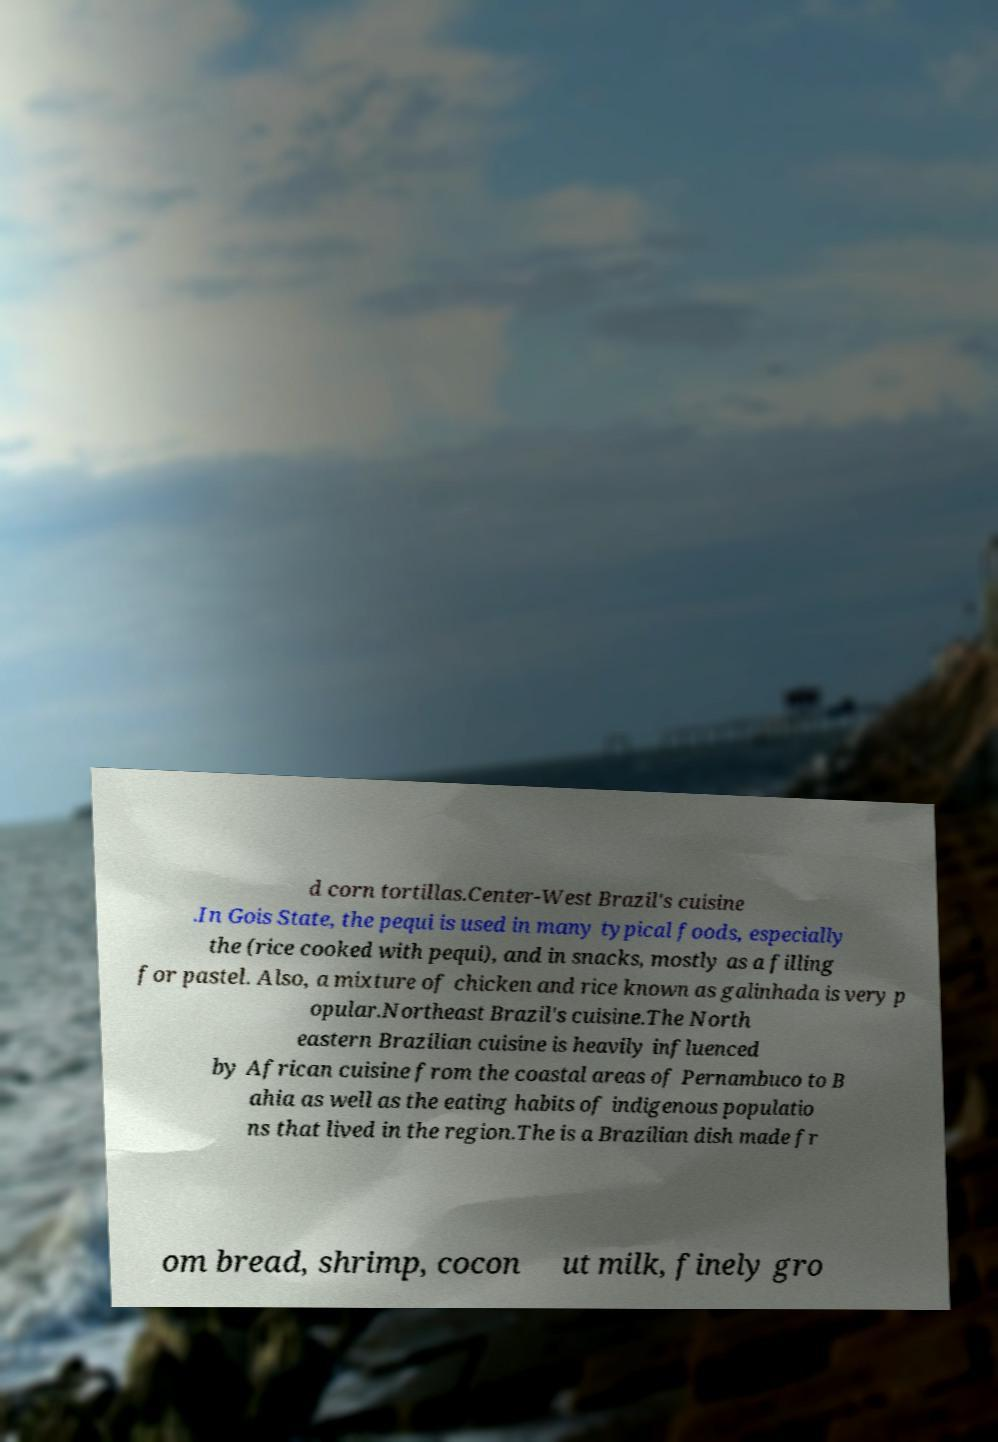I need the written content from this picture converted into text. Can you do that? d corn tortillas.Center-West Brazil's cuisine .In Gois State, the pequi is used in many typical foods, especially the (rice cooked with pequi), and in snacks, mostly as a filling for pastel. Also, a mixture of chicken and rice known as galinhada is very p opular.Northeast Brazil's cuisine.The North eastern Brazilian cuisine is heavily influenced by African cuisine from the coastal areas of Pernambuco to B ahia as well as the eating habits of indigenous populatio ns that lived in the region.The is a Brazilian dish made fr om bread, shrimp, cocon ut milk, finely gro 